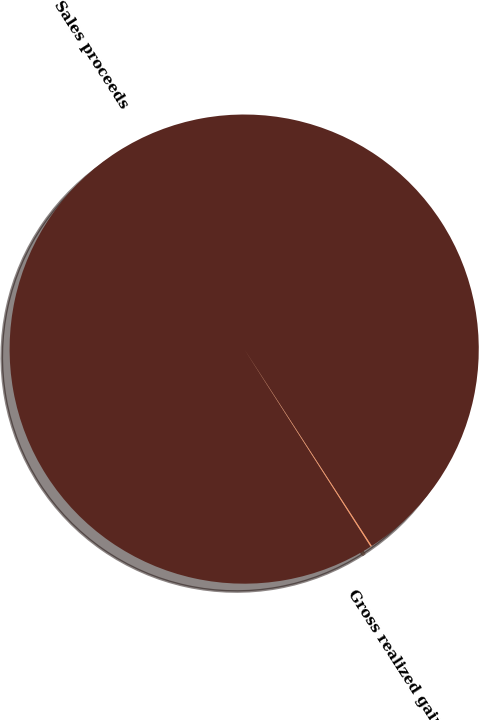Convert chart. <chart><loc_0><loc_0><loc_500><loc_500><pie_chart><fcel>Sales proceeds<fcel>Gross realized gains<nl><fcel>99.91%<fcel>0.09%<nl></chart> 